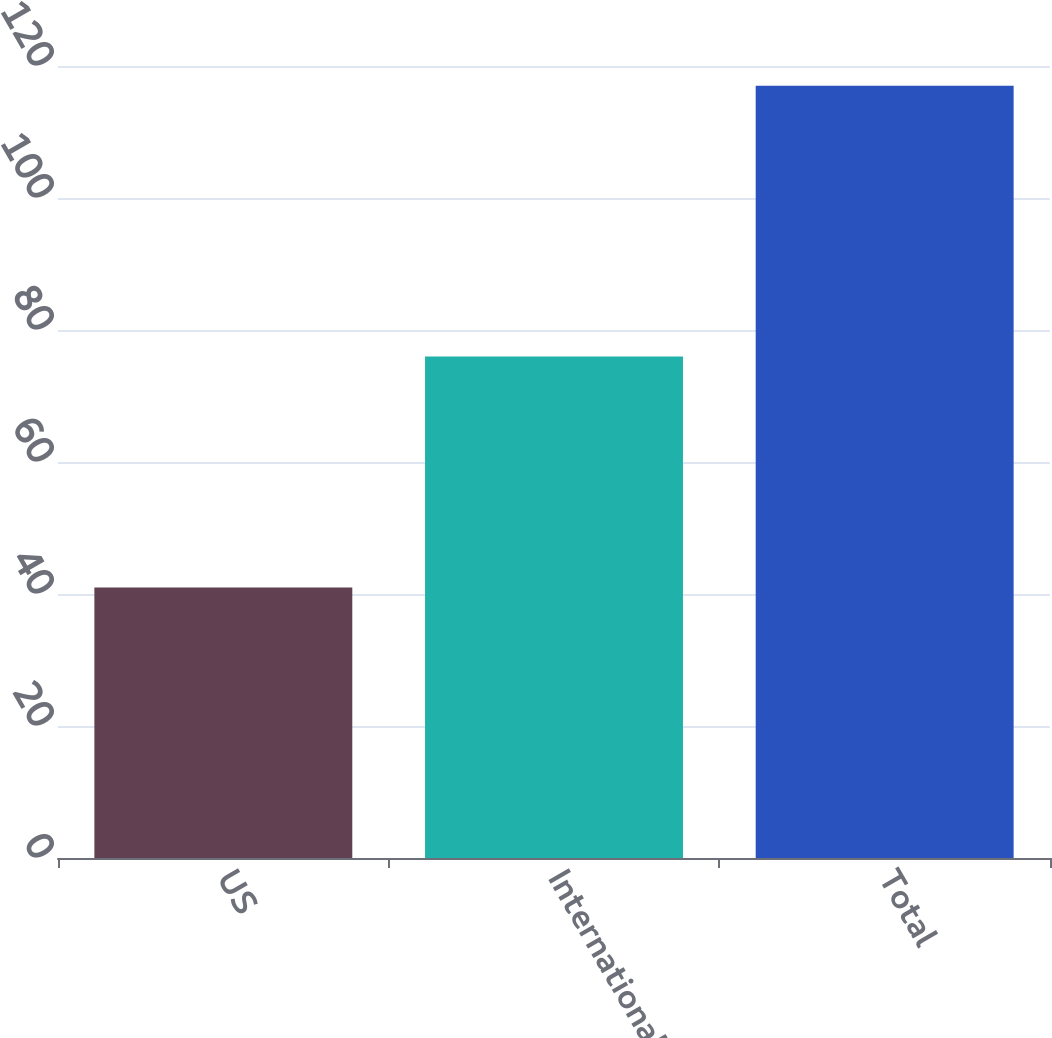<chart> <loc_0><loc_0><loc_500><loc_500><bar_chart><fcel>US<fcel>International<fcel>Total<nl><fcel>41<fcel>76<fcel>117<nl></chart> 